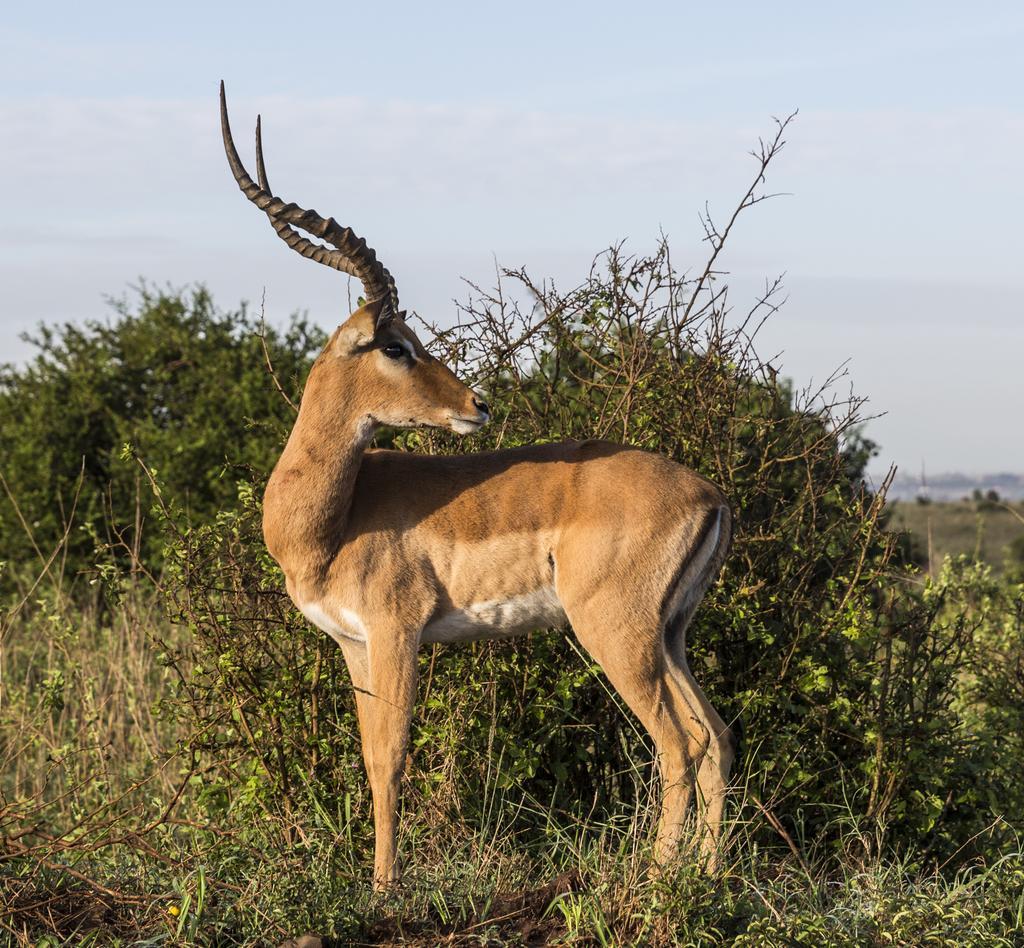Could you give a brief overview of what you see in this image? In this image there is a deer standing on the land having few grass, plants on it. Top of image there is sky. 